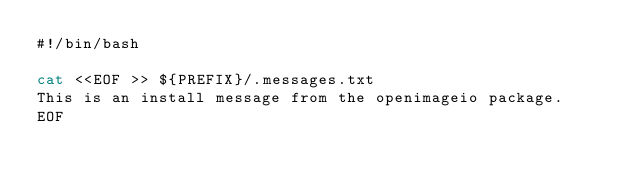Convert code to text. <code><loc_0><loc_0><loc_500><loc_500><_Bash_>#!/bin/bash

cat <<EOF >> ${PREFIX}/.messages.txt
This is an install message from the openimageio package.
EOF
</code> 